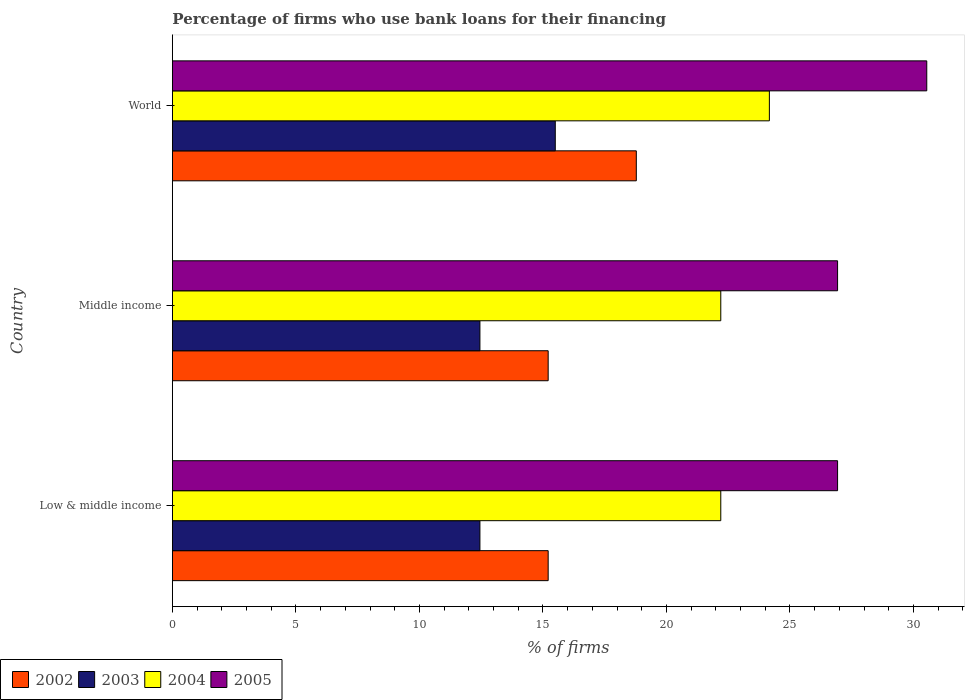How many groups of bars are there?
Your answer should be compact. 3. Are the number of bars per tick equal to the number of legend labels?
Your answer should be compact. Yes. Are the number of bars on each tick of the Y-axis equal?
Give a very brief answer. Yes. How many bars are there on the 1st tick from the bottom?
Your response must be concise. 4. What is the percentage of firms who use bank loans for their financing in 2003 in Middle income?
Keep it short and to the point. 12.45. Across all countries, what is the maximum percentage of firms who use bank loans for their financing in 2002?
Offer a very short reply. 18.78. Across all countries, what is the minimum percentage of firms who use bank loans for their financing in 2002?
Offer a very short reply. 15.21. In which country was the percentage of firms who use bank loans for their financing in 2003 maximum?
Provide a short and direct response. World. In which country was the percentage of firms who use bank loans for their financing in 2002 minimum?
Your response must be concise. Low & middle income. What is the total percentage of firms who use bank loans for their financing in 2004 in the graph?
Offer a terse response. 68.57. What is the difference between the percentage of firms who use bank loans for their financing in 2004 in Low & middle income and that in Middle income?
Make the answer very short. 0. What is the difference between the percentage of firms who use bank loans for their financing in 2004 in Middle income and the percentage of firms who use bank loans for their financing in 2005 in Low & middle income?
Make the answer very short. -4.73. What is the average percentage of firms who use bank loans for their financing in 2004 per country?
Give a very brief answer. 22.86. What is the difference between the percentage of firms who use bank loans for their financing in 2002 and percentage of firms who use bank loans for their financing in 2003 in World?
Offer a terse response. 3.28. In how many countries, is the percentage of firms who use bank loans for their financing in 2005 greater than 15 %?
Your response must be concise. 3. What is the ratio of the percentage of firms who use bank loans for their financing in 2004 in Low & middle income to that in World?
Offer a very short reply. 0.92. Is the percentage of firms who use bank loans for their financing in 2002 in Low & middle income less than that in World?
Offer a terse response. Yes. Is the difference between the percentage of firms who use bank loans for their financing in 2002 in Low & middle income and World greater than the difference between the percentage of firms who use bank loans for their financing in 2003 in Low & middle income and World?
Keep it short and to the point. No. What is the difference between the highest and the second highest percentage of firms who use bank loans for their financing in 2003?
Provide a short and direct response. 3.05. What is the difference between the highest and the lowest percentage of firms who use bank loans for their financing in 2004?
Keep it short and to the point. 1.97. In how many countries, is the percentage of firms who use bank loans for their financing in 2005 greater than the average percentage of firms who use bank loans for their financing in 2005 taken over all countries?
Offer a terse response. 1. Is the sum of the percentage of firms who use bank loans for their financing in 2002 in Low & middle income and Middle income greater than the maximum percentage of firms who use bank loans for their financing in 2004 across all countries?
Give a very brief answer. Yes. Is it the case that in every country, the sum of the percentage of firms who use bank loans for their financing in 2005 and percentage of firms who use bank loans for their financing in 2003 is greater than the sum of percentage of firms who use bank loans for their financing in 2002 and percentage of firms who use bank loans for their financing in 2004?
Your answer should be very brief. Yes. Is it the case that in every country, the sum of the percentage of firms who use bank loans for their financing in 2005 and percentage of firms who use bank loans for their financing in 2004 is greater than the percentage of firms who use bank loans for their financing in 2003?
Give a very brief answer. Yes. Where does the legend appear in the graph?
Provide a short and direct response. Bottom left. What is the title of the graph?
Ensure brevity in your answer.  Percentage of firms who use bank loans for their financing. Does "2009" appear as one of the legend labels in the graph?
Give a very brief answer. No. What is the label or title of the X-axis?
Keep it short and to the point. % of firms. What is the % of firms in 2002 in Low & middle income?
Offer a very short reply. 15.21. What is the % of firms in 2003 in Low & middle income?
Offer a terse response. 12.45. What is the % of firms in 2004 in Low & middle income?
Make the answer very short. 22.2. What is the % of firms in 2005 in Low & middle income?
Provide a succinct answer. 26.93. What is the % of firms of 2002 in Middle income?
Make the answer very short. 15.21. What is the % of firms of 2003 in Middle income?
Ensure brevity in your answer.  12.45. What is the % of firms in 2004 in Middle income?
Ensure brevity in your answer.  22.2. What is the % of firms in 2005 in Middle income?
Your answer should be very brief. 26.93. What is the % of firms of 2002 in World?
Make the answer very short. 18.78. What is the % of firms in 2003 in World?
Provide a succinct answer. 15.5. What is the % of firms in 2004 in World?
Your answer should be compact. 24.17. What is the % of firms in 2005 in World?
Give a very brief answer. 30.54. Across all countries, what is the maximum % of firms of 2002?
Ensure brevity in your answer.  18.78. Across all countries, what is the maximum % of firms in 2003?
Make the answer very short. 15.5. Across all countries, what is the maximum % of firms in 2004?
Provide a succinct answer. 24.17. Across all countries, what is the maximum % of firms of 2005?
Keep it short and to the point. 30.54. Across all countries, what is the minimum % of firms of 2002?
Provide a short and direct response. 15.21. Across all countries, what is the minimum % of firms of 2003?
Offer a very short reply. 12.45. Across all countries, what is the minimum % of firms in 2004?
Your answer should be very brief. 22.2. Across all countries, what is the minimum % of firms of 2005?
Provide a succinct answer. 26.93. What is the total % of firms of 2002 in the graph?
Your response must be concise. 49.21. What is the total % of firms in 2003 in the graph?
Offer a very short reply. 40.4. What is the total % of firms in 2004 in the graph?
Offer a terse response. 68.57. What is the total % of firms in 2005 in the graph?
Your response must be concise. 84.39. What is the difference between the % of firms in 2003 in Low & middle income and that in Middle income?
Your answer should be compact. 0. What is the difference between the % of firms in 2004 in Low & middle income and that in Middle income?
Give a very brief answer. 0. What is the difference between the % of firms in 2005 in Low & middle income and that in Middle income?
Your answer should be compact. 0. What is the difference between the % of firms in 2002 in Low & middle income and that in World?
Your response must be concise. -3.57. What is the difference between the % of firms in 2003 in Low & middle income and that in World?
Give a very brief answer. -3.05. What is the difference between the % of firms in 2004 in Low & middle income and that in World?
Your response must be concise. -1.97. What is the difference between the % of firms of 2005 in Low & middle income and that in World?
Your response must be concise. -3.61. What is the difference between the % of firms in 2002 in Middle income and that in World?
Provide a short and direct response. -3.57. What is the difference between the % of firms of 2003 in Middle income and that in World?
Your response must be concise. -3.05. What is the difference between the % of firms of 2004 in Middle income and that in World?
Give a very brief answer. -1.97. What is the difference between the % of firms of 2005 in Middle income and that in World?
Provide a short and direct response. -3.61. What is the difference between the % of firms in 2002 in Low & middle income and the % of firms in 2003 in Middle income?
Provide a succinct answer. 2.76. What is the difference between the % of firms of 2002 in Low & middle income and the % of firms of 2004 in Middle income?
Your answer should be compact. -6.99. What is the difference between the % of firms in 2002 in Low & middle income and the % of firms in 2005 in Middle income?
Provide a succinct answer. -11.72. What is the difference between the % of firms of 2003 in Low & middle income and the % of firms of 2004 in Middle income?
Provide a succinct answer. -9.75. What is the difference between the % of firms of 2003 in Low & middle income and the % of firms of 2005 in Middle income?
Ensure brevity in your answer.  -14.48. What is the difference between the % of firms in 2004 in Low & middle income and the % of firms in 2005 in Middle income?
Keep it short and to the point. -4.73. What is the difference between the % of firms of 2002 in Low & middle income and the % of firms of 2003 in World?
Provide a succinct answer. -0.29. What is the difference between the % of firms of 2002 in Low & middle income and the % of firms of 2004 in World?
Ensure brevity in your answer.  -8.95. What is the difference between the % of firms of 2002 in Low & middle income and the % of firms of 2005 in World?
Your answer should be very brief. -15.33. What is the difference between the % of firms of 2003 in Low & middle income and the % of firms of 2004 in World?
Your answer should be very brief. -11.72. What is the difference between the % of firms in 2003 in Low & middle income and the % of firms in 2005 in World?
Give a very brief answer. -18.09. What is the difference between the % of firms in 2004 in Low & middle income and the % of firms in 2005 in World?
Give a very brief answer. -8.34. What is the difference between the % of firms of 2002 in Middle income and the % of firms of 2003 in World?
Give a very brief answer. -0.29. What is the difference between the % of firms in 2002 in Middle income and the % of firms in 2004 in World?
Offer a terse response. -8.95. What is the difference between the % of firms of 2002 in Middle income and the % of firms of 2005 in World?
Your response must be concise. -15.33. What is the difference between the % of firms of 2003 in Middle income and the % of firms of 2004 in World?
Provide a short and direct response. -11.72. What is the difference between the % of firms of 2003 in Middle income and the % of firms of 2005 in World?
Your answer should be compact. -18.09. What is the difference between the % of firms of 2004 in Middle income and the % of firms of 2005 in World?
Your answer should be compact. -8.34. What is the average % of firms of 2002 per country?
Keep it short and to the point. 16.4. What is the average % of firms of 2003 per country?
Your answer should be very brief. 13.47. What is the average % of firms in 2004 per country?
Provide a succinct answer. 22.86. What is the average % of firms of 2005 per country?
Keep it short and to the point. 28.13. What is the difference between the % of firms of 2002 and % of firms of 2003 in Low & middle income?
Offer a terse response. 2.76. What is the difference between the % of firms of 2002 and % of firms of 2004 in Low & middle income?
Provide a succinct answer. -6.99. What is the difference between the % of firms in 2002 and % of firms in 2005 in Low & middle income?
Provide a succinct answer. -11.72. What is the difference between the % of firms of 2003 and % of firms of 2004 in Low & middle income?
Ensure brevity in your answer.  -9.75. What is the difference between the % of firms in 2003 and % of firms in 2005 in Low & middle income?
Offer a very short reply. -14.48. What is the difference between the % of firms of 2004 and % of firms of 2005 in Low & middle income?
Your answer should be compact. -4.73. What is the difference between the % of firms of 2002 and % of firms of 2003 in Middle income?
Provide a short and direct response. 2.76. What is the difference between the % of firms of 2002 and % of firms of 2004 in Middle income?
Provide a short and direct response. -6.99. What is the difference between the % of firms in 2002 and % of firms in 2005 in Middle income?
Provide a succinct answer. -11.72. What is the difference between the % of firms in 2003 and % of firms in 2004 in Middle income?
Make the answer very short. -9.75. What is the difference between the % of firms of 2003 and % of firms of 2005 in Middle income?
Provide a short and direct response. -14.48. What is the difference between the % of firms of 2004 and % of firms of 2005 in Middle income?
Keep it short and to the point. -4.73. What is the difference between the % of firms in 2002 and % of firms in 2003 in World?
Offer a terse response. 3.28. What is the difference between the % of firms in 2002 and % of firms in 2004 in World?
Ensure brevity in your answer.  -5.39. What is the difference between the % of firms in 2002 and % of firms in 2005 in World?
Ensure brevity in your answer.  -11.76. What is the difference between the % of firms in 2003 and % of firms in 2004 in World?
Your answer should be compact. -8.67. What is the difference between the % of firms of 2003 and % of firms of 2005 in World?
Your answer should be very brief. -15.04. What is the difference between the % of firms of 2004 and % of firms of 2005 in World?
Keep it short and to the point. -6.37. What is the ratio of the % of firms in 2003 in Low & middle income to that in Middle income?
Your response must be concise. 1. What is the ratio of the % of firms in 2004 in Low & middle income to that in Middle income?
Provide a short and direct response. 1. What is the ratio of the % of firms of 2005 in Low & middle income to that in Middle income?
Provide a succinct answer. 1. What is the ratio of the % of firms in 2002 in Low & middle income to that in World?
Provide a short and direct response. 0.81. What is the ratio of the % of firms of 2003 in Low & middle income to that in World?
Your response must be concise. 0.8. What is the ratio of the % of firms in 2004 in Low & middle income to that in World?
Give a very brief answer. 0.92. What is the ratio of the % of firms in 2005 in Low & middle income to that in World?
Offer a terse response. 0.88. What is the ratio of the % of firms in 2002 in Middle income to that in World?
Your response must be concise. 0.81. What is the ratio of the % of firms in 2003 in Middle income to that in World?
Ensure brevity in your answer.  0.8. What is the ratio of the % of firms of 2004 in Middle income to that in World?
Ensure brevity in your answer.  0.92. What is the ratio of the % of firms in 2005 in Middle income to that in World?
Make the answer very short. 0.88. What is the difference between the highest and the second highest % of firms of 2002?
Offer a terse response. 3.57. What is the difference between the highest and the second highest % of firms of 2003?
Keep it short and to the point. 3.05. What is the difference between the highest and the second highest % of firms of 2004?
Provide a succinct answer. 1.97. What is the difference between the highest and the second highest % of firms in 2005?
Provide a short and direct response. 3.61. What is the difference between the highest and the lowest % of firms in 2002?
Your response must be concise. 3.57. What is the difference between the highest and the lowest % of firms in 2003?
Ensure brevity in your answer.  3.05. What is the difference between the highest and the lowest % of firms in 2004?
Give a very brief answer. 1.97. What is the difference between the highest and the lowest % of firms of 2005?
Offer a terse response. 3.61. 